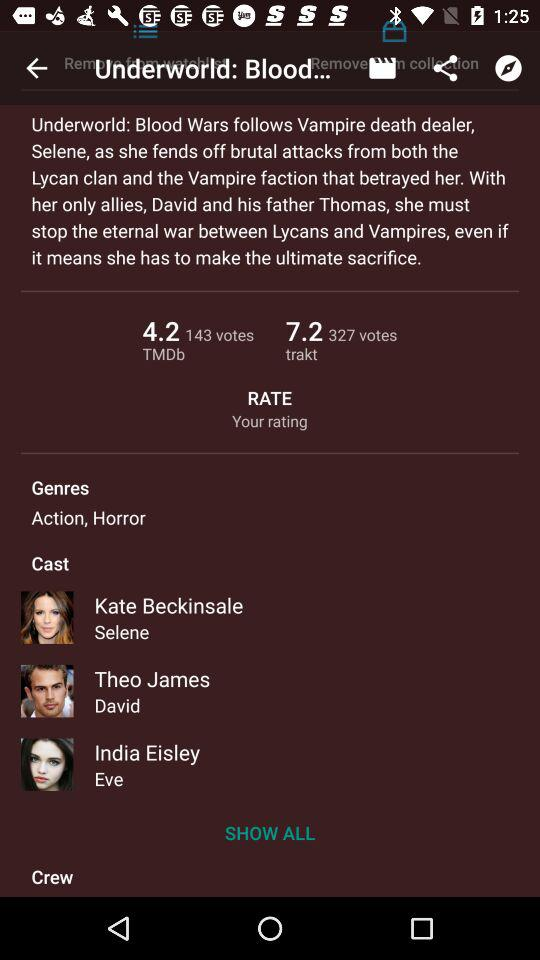What is the title of the movie? The title of the movie is "Underworld: Blood Wars". 